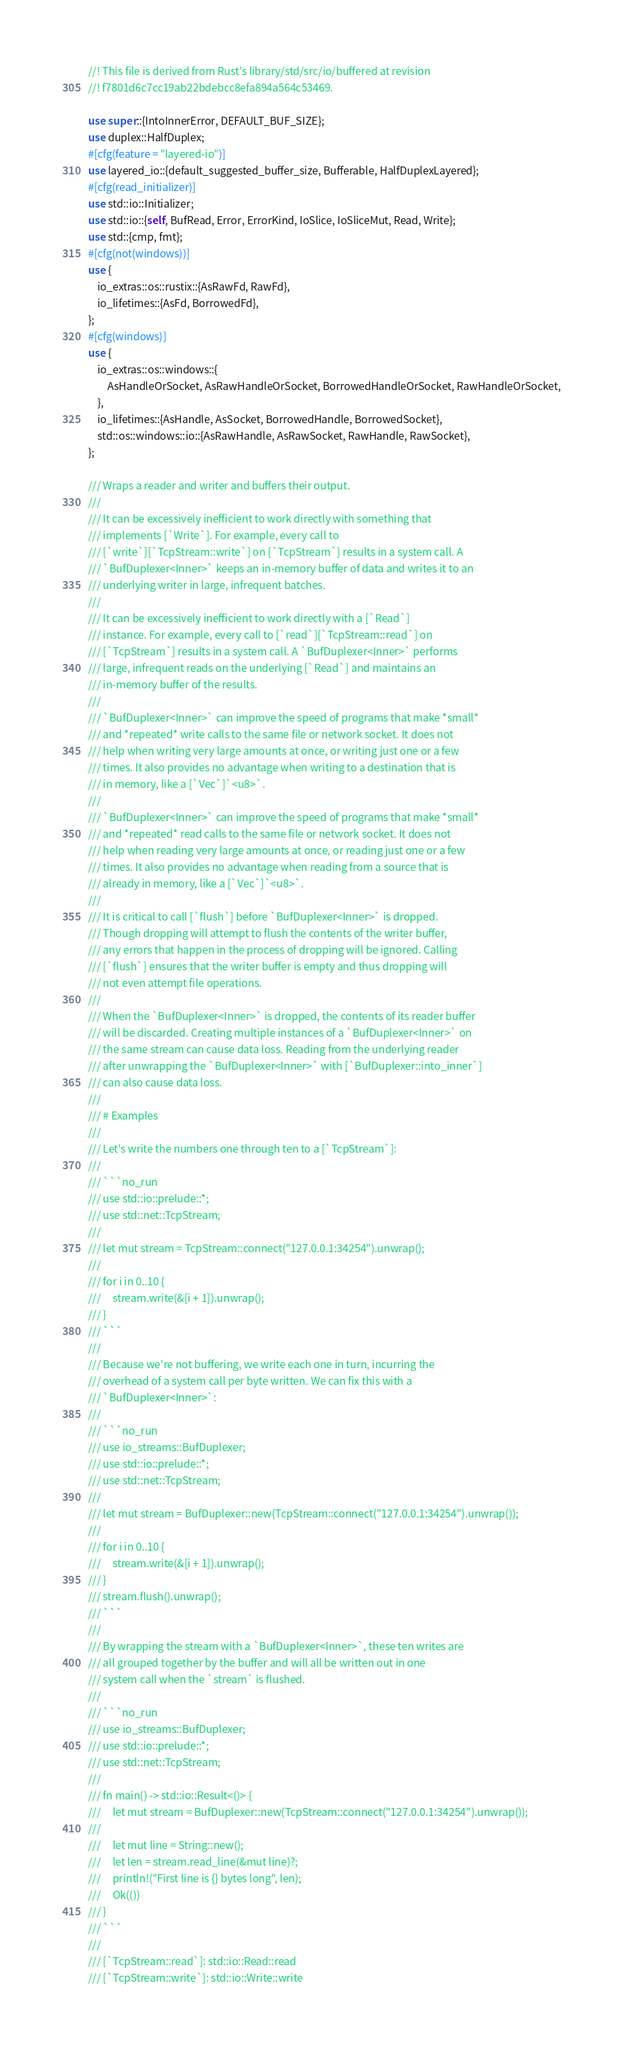<code> <loc_0><loc_0><loc_500><loc_500><_Rust_>//! This file is derived from Rust's library/std/src/io/buffered at revision
//! f7801d6c7cc19ab22bdebcc8efa894a564c53469.

use super::{IntoInnerError, DEFAULT_BUF_SIZE};
use duplex::HalfDuplex;
#[cfg(feature = "layered-io")]
use layered_io::{default_suggested_buffer_size, Bufferable, HalfDuplexLayered};
#[cfg(read_initializer)]
use std::io::Initializer;
use std::io::{self, BufRead, Error, ErrorKind, IoSlice, IoSliceMut, Read, Write};
use std::{cmp, fmt};
#[cfg(not(windows))]
use {
    io_extras::os::rustix::{AsRawFd, RawFd},
    io_lifetimes::{AsFd, BorrowedFd},
};
#[cfg(windows)]
use {
    io_extras::os::windows::{
        AsHandleOrSocket, AsRawHandleOrSocket, BorrowedHandleOrSocket, RawHandleOrSocket,
    },
    io_lifetimes::{AsHandle, AsSocket, BorrowedHandle, BorrowedSocket},
    std::os::windows::io::{AsRawHandle, AsRawSocket, RawHandle, RawSocket},
};

/// Wraps a reader and writer and buffers their output.
///
/// It can be excessively inefficient to work directly with something that
/// implements [`Write`]. For example, every call to
/// [`write`][`TcpStream::write`] on [`TcpStream`] results in a system call. A
/// `BufDuplexer<Inner>` keeps an in-memory buffer of data and writes it to an
/// underlying writer in large, infrequent batches.
///
/// It can be excessively inefficient to work directly with a [`Read`]
/// instance. For example, every call to [`read`][`TcpStream::read`] on
/// [`TcpStream`] results in a system call. A `BufDuplexer<Inner>` performs
/// large, infrequent reads on the underlying [`Read`] and maintains an
/// in-memory buffer of the results.
///
/// `BufDuplexer<Inner>` can improve the speed of programs that make *small*
/// and *repeated* write calls to the same file or network socket. It does not
/// help when writing very large amounts at once, or writing just one or a few
/// times. It also provides no advantage when writing to a destination that is
/// in memory, like a [`Vec`]`<u8>`.
///
/// `BufDuplexer<Inner>` can improve the speed of programs that make *small*
/// and *repeated* read calls to the same file or network socket. It does not
/// help when reading very large amounts at once, or reading just one or a few
/// times. It also provides no advantage when reading from a source that is
/// already in memory, like a [`Vec`]`<u8>`.
///
/// It is critical to call [`flush`] before `BufDuplexer<Inner>` is dropped.
/// Though dropping will attempt to flush the contents of the writer buffer,
/// any errors that happen in the process of dropping will be ignored. Calling
/// [`flush`] ensures that the writer buffer is empty and thus dropping will
/// not even attempt file operations.
///
/// When the `BufDuplexer<Inner>` is dropped, the contents of its reader buffer
/// will be discarded. Creating multiple instances of a `BufDuplexer<Inner>` on
/// the same stream can cause data loss. Reading from the underlying reader
/// after unwrapping the `BufDuplexer<Inner>` with [`BufDuplexer::into_inner`]
/// can also cause data loss.
///
/// # Examples
///
/// Let's write the numbers one through ten to a [`TcpStream`]:
///
/// ```no_run
/// use std::io::prelude::*;
/// use std::net::TcpStream;
///
/// let mut stream = TcpStream::connect("127.0.0.1:34254").unwrap();
///
/// for i in 0..10 {
///     stream.write(&[i + 1]).unwrap();
/// }
/// ```
///
/// Because we're not buffering, we write each one in turn, incurring the
/// overhead of a system call per byte written. We can fix this with a
/// `BufDuplexer<Inner>`:
///
/// ```no_run
/// use io_streams::BufDuplexer;
/// use std::io::prelude::*;
/// use std::net::TcpStream;
///
/// let mut stream = BufDuplexer::new(TcpStream::connect("127.0.0.1:34254").unwrap());
///
/// for i in 0..10 {
///     stream.write(&[i + 1]).unwrap();
/// }
/// stream.flush().unwrap();
/// ```
///
/// By wrapping the stream with a `BufDuplexer<Inner>`, these ten writes are
/// all grouped together by the buffer and will all be written out in one
/// system call when the `stream` is flushed.
///
/// ```no_run
/// use io_streams::BufDuplexer;
/// use std::io::prelude::*;
/// use std::net::TcpStream;
///
/// fn main() -> std::io::Result<()> {
///     let mut stream = BufDuplexer::new(TcpStream::connect("127.0.0.1:34254").unwrap());
///
///     let mut line = String::new();
///     let len = stream.read_line(&mut line)?;
///     println!("First line is {} bytes long", len);
///     Ok(())
/// }
/// ```
///
/// [`TcpStream::read`]: std::io::Read::read
/// [`TcpStream::write`]: std::io::Write::write</code> 